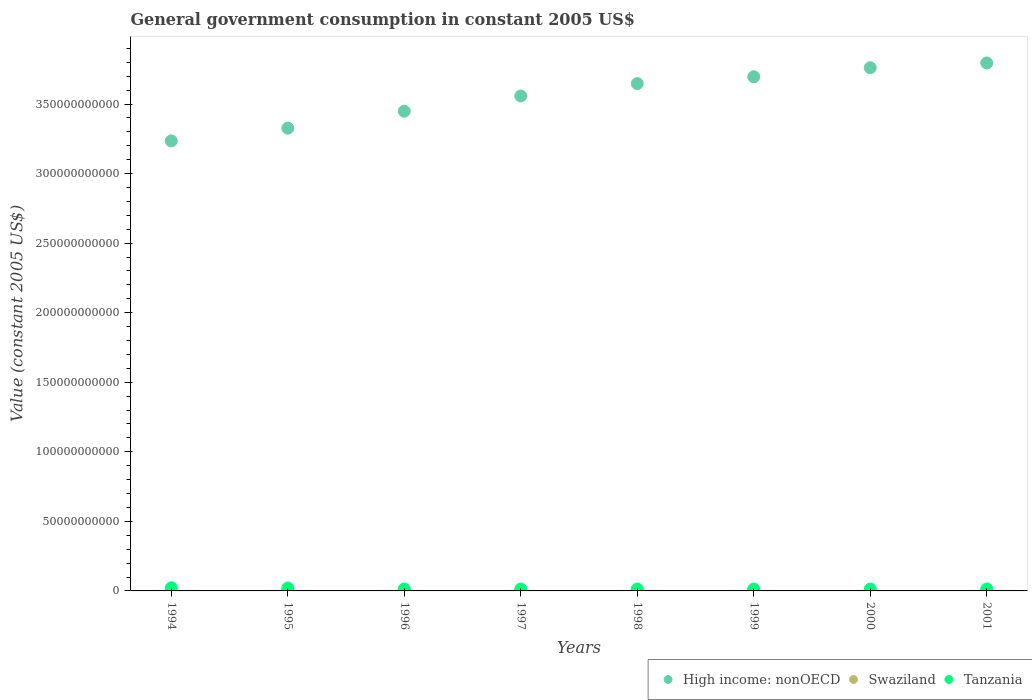What is the government conusmption in Tanzania in 1995?
Keep it short and to the point. 2.11e+09. Across all years, what is the maximum government conusmption in Swaziland?
Offer a terse response. 3.47e+08. Across all years, what is the minimum government conusmption in Tanzania?
Make the answer very short. 1.31e+09. In which year was the government conusmption in Tanzania maximum?
Provide a short and direct response. 1994. In which year was the government conusmption in Tanzania minimum?
Provide a succinct answer. 1999. What is the total government conusmption in High income: nonOECD in the graph?
Your answer should be compact. 2.85e+12. What is the difference between the government conusmption in Swaziland in 1995 and that in 1996?
Offer a very short reply. -5.25e+07. What is the difference between the government conusmption in Tanzania in 1997 and the government conusmption in Swaziland in 1999?
Keep it short and to the point. 1.00e+09. What is the average government conusmption in Swaziland per year?
Give a very brief answer. 2.76e+08. In the year 2001, what is the difference between the government conusmption in High income: nonOECD and government conusmption in Tanzania?
Keep it short and to the point. 3.78e+11. In how many years, is the government conusmption in High income: nonOECD greater than 70000000000 US$?
Your response must be concise. 8. What is the ratio of the government conusmption in Swaziland in 1994 to that in 1995?
Ensure brevity in your answer.  1.01. What is the difference between the highest and the second highest government conusmption in Swaziland?
Offer a terse response. 6.19e+07. What is the difference between the highest and the lowest government conusmption in Swaziland?
Make the answer very short. 1.14e+08. Is the sum of the government conusmption in High income: nonOECD in 1995 and 1999 greater than the maximum government conusmption in Tanzania across all years?
Offer a very short reply. Yes. Does the government conusmption in Swaziland monotonically increase over the years?
Provide a short and direct response. No. Is the government conusmption in Swaziland strictly greater than the government conusmption in Tanzania over the years?
Offer a terse response. No. Is the government conusmption in Swaziland strictly less than the government conusmption in Tanzania over the years?
Provide a short and direct response. Yes. How many dotlines are there?
Your response must be concise. 3. How many years are there in the graph?
Give a very brief answer. 8. Are the values on the major ticks of Y-axis written in scientific E-notation?
Make the answer very short. No. Does the graph contain any zero values?
Your answer should be compact. No. Does the graph contain grids?
Offer a very short reply. No. Where does the legend appear in the graph?
Your answer should be compact. Bottom right. How are the legend labels stacked?
Provide a succinct answer. Horizontal. What is the title of the graph?
Keep it short and to the point. General government consumption in constant 2005 US$. Does "Bahrain" appear as one of the legend labels in the graph?
Ensure brevity in your answer.  No. What is the label or title of the Y-axis?
Provide a succinct answer. Value (constant 2005 US$). What is the Value (constant 2005 US$) in High income: nonOECD in 1994?
Give a very brief answer. 3.24e+11. What is the Value (constant 2005 US$) in Swaziland in 1994?
Provide a succinct answer. 2.36e+08. What is the Value (constant 2005 US$) of Tanzania in 1994?
Your answer should be compact. 2.29e+09. What is the Value (constant 2005 US$) of High income: nonOECD in 1995?
Offer a very short reply. 3.33e+11. What is the Value (constant 2005 US$) in Swaziland in 1995?
Offer a terse response. 2.33e+08. What is the Value (constant 2005 US$) of Tanzania in 1995?
Give a very brief answer. 2.11e+09. What is the Value (constant 2005 US$) in High income: nonOECD in 1996?
Your answer should be very brief. 3.45e+11. What is the Value (constant 2005 US$) of Swaziland in 1996?
Ensure brevity in your answer.  2.86e+08. What is the Value (constant 2005 US$) in Tanzania in 1996?
Make the answer very short. 1.41e+09. What is the Value (constant 2005 US$) in High income: nonOECD in 1997?
Give a very brief answer. 3.56e+11. What is the Value (constant 2005 US$) of Swaziland in 1997?
Your answer should be very brief. 2.72e+08. What is the Value (constant 2005 US$) of Tanzania in 1997?
Give a very brief answer. 1.35e+09. What is the Value (constant 2005 US$) in High income: nonOECD in 1998?
Your response must be concise. 3.65e+11. What is the Value (constant 2005 US$) in Swaziland in 1998?
Keep it short and to the point. 2.79e+08. What is the Value (constant 2005 US$) of Tanzania in 1998?
Provide a short and direct response. 1.33e+09. What is the Value (constant 2005 US$) of High income: nonOECD in 1999?
Give a very brief answer. 3.70e+11. What is the Value (constant 2005 US$) of Swaziland in 1999?
Keep it short and to the point. 3.47e+08. What is the Value (constant 2005 US$) of Tanzania in 1999?
Provide a succinct answer. 1.31e+09. What is the Value (constant 2005 US$) in High income: nonOECD in 2000?
Offer a terse response. 3.76e+11. What is the Value (constant 2005 US$) in Swaziland in 2000?
Give a very brief answer. 2.81e+08. What is the Value (constant 2005 US$) of Tanzania in 2000?
Offer a very short reply. 1.34e+09. What is the Value (constant 2005 US$) in High income: nonOECD in 2001?
Your answer should be very brief. 3.80e+11. What is the Value (constant 2005 US$) of Swaziland in 2001?
Provide a short and direct response. 2.70e+08. What is the Value (constant 2005 US$) of Tanzania in 2001?
Offer a very short reply. 1.42e+09. Across all years, what is the maximum Value (constant 2005 US$) of High income: nonOECD?
Ensure brevity in your answer.  3.80e+11. Across all years, what is the maximum Value (constant 2005 US$) of Swaziland?
Ensure brevity in your answer.  3.47e+08. Across all years, what is the maximum Value (constant 2005 US$) in Tanzania?
Your answer should be very brief. 2.29e+09. Across all years, what is the minimum Value (constant 2005 US$) in High income: nonOECD?
Offer a terse response. 3.24e+11. Across all years, what is the minimum Value (constant 2005 US$) in Swaziland?
Offer a very short reply. 2.33e+08. Across all years, what is the minimum Value (constant 2005 US$) in Tanzania?
Your answer should be very brief. 1.31e+09. What is the total Value (constant 2005 US$) of High income: nonOECD in the graph?
Offer a terse response. 2.85e+12. What is the total Value (constant 2005 US$) in Swaziland in the graph?
Make the answer very short. 2.21e+09. What is the total Value (constant 2005 US$) in Tanzania in the graph?
Your response must be concise. 1.25e+1. What is the difference between the Value (constant 2005 US$) in High income: nonOECD in 1994 and that in 1995?
Provide a succinct answer. -9.17e+09. What is the difference between the Value (constant 2005 US$) in Swaziland in 1994 and that in 1995?
Your answer should be very brief. 3.29e+06. What is the difference between the Value (constant 2005 US$) in Tanzania in 1994 and that in 1995?
Offer a very short reply. 1.83e+08. What is the difference between the Value (constant 2005 US$) of High income: nonOECD in 1994 and that in 1996?
Make the answer very short. -2.14e+1. What is the difference between the Value (constant 2005 US$) in Swaziland in 1994 and that in 1996?
Your answer should be compact. -4.93e+07. What is the difference between the Value (constant 2005 US$) in Tanzania in 1994 and that in 1996?
Keep it short and to the point. 8.76e+08. What is the difference between the Value (constant 2005 US$) in High income: nonOECD in 1994 and that in 1997?
Your answer should be compact. -3.23e+1. What is the difference between the Value (constant 2005 US$) of Swaziland in 1994 and that in 1997?
Your response must be concise. -3.62e+07. What is the difference between the Value (constant 2005 US$) of Tanzania in 1994 and that in 1997?
Your answer should be compact. 9.38e+08. What is the difference between the Value (constant 2005 US$) in High income: nonOECD in 1994 and that in 1998?
Give a very brief answer. -4.12e+1. What is the difference between the Value (constant 2005 US$) of Swaziland in 1994 and that in 1998?
Keep it short and to the point. -4.31e+07. What is the difference between the Value (constant 2005 US$) of Tanzania in 1994 and that in 1998?
Make the answer very short. 9.62e+08. What is the difference between the Value (constant 2005 US$) in High income: nonOECD in 1994 and that in 1999?
Your answer should be very brief. -4.61e+1. What is the difference between the Value (constant 2005 US$) in Swaziland in 1994 and that in 1999?
Your answer should be compact. -1.11e+08. What is the difference between the Value (constant 2005 US$) of Tanzania in 1994 and that in 1999?
Your answer should be compact. 9.83e+08. What is the difference between the Value (constant 2005 US$) of High income: nonOECD in 1994 and that in 2000?
Your answer should be compact. -5.26e+1. What is the difference between the Value (constant 2005 US$) in Swaziland in 1994 and that in 2000?
Offer a very short reply. -4.49e+07. What is the difference between the Value (constant 2005 US$) of Tanzania in 1994 and that in 2000?
Make the answer very short. 9.54e+08. What is the difference between the Value (constant 2005 US$) in High income: nonOECD in 1994 and that in 2001?
Make the answer very short. -5.60e+1. What is the difference between the Value (constant 2005 US$) in Swaziland in 1994 and that in 2001?
Make the answer very short. -3.41e+07. What is the difference between the Value (constant 2005 US$) of Tanzania in 1994 and that in 2001?
Offer a very short reply. 8.74e+08. What is the difference between the Value (constant 2005 US$) of High income: nonOECD in 1995 and that in 1996?
Provide a succinct answer. -1.22e+1. What is the difference between the Value (constant 2005 US$) of Swaziland in 1995 and that in 1996?
Offer a very short reply. -5.25e+07. What is the difference between the Value (constant 2005 US$) of Tanzania in 1995 and that in 1996?
Provide a succinct answer. 6.93e+08. What is the difference between the Value (constant 2005 US$) of High income: nonOECD in 1995 and that in 1997?
Your response must be concise. -2.31e+1. What is the difference between the Value (constant 2005 US$) of Swaziland in 1995 and that in 1997?
Provide a short and direct response. -3.94e+07. What is the difference between the Value (constant 2005 US$) of Tanzania in 1995 and that in 1997?
Provide a succinct answer. 7.56e+08. What is the difference between the Value (constant 2005 US$) in High income: nonOECD in 1995 and that in 1998?
Your answer should be compact. -3.20e+1. What is the difference between the Value (constant 2005 US$) in Swaziland in 1995 and that in 1998?
Make the answer very short. -4.63e+07. What is the difference between the Value (constant 2005 US$) of Tanzania in 1995 and that in 1998?
Keep it short and to the point. 7.80e+08. What is the difference between the Value (constant 2005 US$) of High income: nonOECD in 1995 and that in 1999?
Your response must be concise. -3.70e+1. What is the difference between the Value (constant 2005 US$) in Swaziland in 1995 and that in 1999?
Offer a terse response. -1.14e+08. What is the difference between the Value (constant 2005 US$) in Tanzania in 1995 and that in 1999?
Make the answer very short. 8.00e+08. What is the difference between the Value (constant 2005 US$) in High income: nonOECD in 1995 and that in 2000?
Offer a very short reply. -4.34e+1. What is the difference between the Value (constant 2005 US$) of Swaziland in 1995 and that in 2000?
Offer a terse response. -4.82e+07. What is the difference between the Value (constant 2005 US$) in Tanzania in 1995 and that in 2000?
Offer a terse response. 7.72e+08. What is the difference between the Value (constant 2005 US$) in High income: nonOECD in 1995 and that in 2001?
Make the answer very short. -4.69e+1. What is the difference between the Value (constant 2005 US$) in Swaziland in 1995 and that in 2001?
Your answer should be compact. -3.74e+07. What is the difference between the Value (constant 2005 US$) in Tanzania in 1995 and that in 2001?
Provide a succinct answer. 6.92e+08. What is the difference between the Value (constant 2005 US$) in High income: nonOECD in 1996 and that in 1997?
Make the answer very short. -1.09e+1. What is the difference between the Value (constant 2005 US$) in Swaziland in 1996 and that in 1997?
Offer a very short reply. 1.31e+07. What is the difference between the Value (constant 2005 US$) of Tanzania in 1996 and that in 1997?
Keep it short and to the point. 6.24e+07. What is the difference between the Value (constant 2005 US$) of High income: nonOECD in 1996 and that in 1998?
Keep it short and to the point. -1.99e+1. What is the difference between the Value (constant 2005 US$) of Swaziland in 1996 and that in 1998?
Offer a terse response. 6.20e+06. What is the difference between the Value (constant 2005 US$) of Tanzania in 1996 and that in 1998?
Provide a short and direct response. 8.64e+07. What is the difference between the Value (constant 2005 US$) of High income: nonOECD in 1996 and that in 1999?
Your answer should be compact. -2.48e+1. What is the difference between the Value (constant 2005 US$) in Swaziland in 1996 and that in 1999?
Offer a terse response. -6.19e+07. What is the difference between the Value (constant 2005 US$) of Tanzania in 1996 and that in 1999?
Provide a short and direct response. 1.07e+08. What is the difference between the Value (constant 2005 US$) of High income: nonOECD in 1996 and that in 2000?
Your answer should be very brief. -3.12e+1. What is the difference between the Value (constant 2005 US$) in Swaziland in 1996 and that in 2000?
Your answer should be very brief. 4.34e+06. What is the difference between the Value (constant 2005 US$) in Tanzania in 1996 and that in 2000?
Your answer should be compact. 7.83e+07. What is the difference between the Value (constant 2005 US$) in High income: nonOECD in 1996 and that in 2001?
Your answer should be compact. -3.47e+1. What is the difference between the Value (constant 2005 US$) of Swaziland in 1996 and that in 2001?
Give a very brief answer. 1.51e+07. What is the difference between the Value (constant 2005 US$) of Tanzania in 1996 and that in 2001?
Offer a terse response. -1.82e+06. What is the difference between the Value (constant 2005 US$) of High income: nonOECD in 1997 and that in 1998?
Keep it short and to the point. -8.92e+09. What is the difference between the Value (constant 2005 US$) in Swaziland in 1997 and that in 1998?
Make the answer very short. -6.90e+06. What is the difference between the Value (constant 2005 US$) in Tanzania in 1997 and that in 1998?
Offer a terse response. 2.41e+07. What is the difference between the Value (constant 2005 US$) in High income: nonOECD in 1997 and that in 1999?
Your answer should be compact. -1.38e+1. What is the difference between the Value (constant 2005 US$) in Swaziland in 1997 and that in 1999?
Provide a short and direct response. -7.50e+07. What is the difference between the Value (constant 2005 US$) in Tanzania in 1997 and that in 1999?
Make the answer very short. 4.45e+07. What is the difference between the Value (constant 2005 US$) in High income: nonOECD in 1997 and that in 2000?
Make the answer very short. -2.03e+1. What is the difference between the Value (constant 2005 US$) of Swaziland in 1997 and that in 2000?
Give a very brief answer. -8.76e+06. What is the difference between the Value (constant 2005 US$) of Tanzania in 1997 and that in 2000?
Offer a terse response. 1.59e+07. What is the difference between the Value (constant 2005 US$) in High income: nonOECD in 1997 and that in 2001?
Make the answer very short. -2.37e+1. What is the difference between the Value (constant 2005 US$) of Swaziland in 1997 and that in 2001?
Your response must be concise. 2.03e+06. What is the difference between the Value (constant 2005 US$) of Tanzania in 1997 and that in 2001?
Ensure brevity in your answer.  -6.42e+07. What is the difference between the Value (constant 2005 US$) in High income: nonOECD in 1998 and that in 1999?
Your response must be concise. -4.91e+09. What is the difference between the Value (constant 2005 US$) of Swaziland in 1998 and that in 1999?
Provide a succinct answer. -6.81e+07. What is the difference between the Value (constant 2005 US$) of Tanzania in 1998 and that in 1999?
Keep it short and to the point. 2.05e+07. What is the difference between the Value (constant 2005 US$) in High income: nonOECD in 1998 and that in 2000?
Provide a succinct answer. -1.14e+1. What is the difference between the Value (constant 2005 US$) in Swaziland in 1998 and that in 2000?
Your response must be concise. -1.86e+06. What is the difference between the Value (constant 2005 US$) in Tanzania in 1998 and that in 2000?
Provide a succinct answer. -8.16e+06. What is the difference between the Value (constant 2005 US$) of High income: nonOECD in 1998 and that in 2001?
Your answer should be very brief. -1.48e+1. What is the difference between the Value (constant 2005 US$) in Swaziland in 1998 and that in 2001?
Offer a terse response. 8.94e+06. What is the difference between the Value (constant 2005 US$) of Tanzania in 1998 and that in 2001?
Offer a very short reply. -8.83e+07. What is the difference between the Value (constant 2005 US$) in High income: nonOECD in 1999 and that in 2000?
Offer a terse response. -6.48e+09. What is the difference between the Value (constant 2005 US$) in Swaziland in 1999 and that in 2000?
Make the answer very short. 6.62e+07. What is the difference between the Value (constant 2005 US$) in Tanzania in 1999 and that in 2000?
Provide a succinct answer. -2.86e+07. What is the difference between the Value (constant 2005 US$) in High income: nonOECD in 1999 and that in 2001?
Offer a terse response. -9.92e+09. What is the difference between the Value (constant 2005 US$) of Swaziland in 1999 and that in 2001?
Provide a succinct answer. 7.70e+07. What is the difference between the Value (constant 2005 US$) in Tanzania in 1999 and that in 2001?
Your answer should be compact. -1.09e+08. What is the difference between the Value (constant 2005 US$) in High income: nonOECD in 2000 and that in 2001?
Make the answer very short. -3.43e+09. What is the difference between the Value (constant 2005 US$) of Swaziland in 2000 and that in 2001?
Keep it short and to the point. 1.08e+07. What is the difference between the Value (constant 2005 US$) of Tanzania in 2000 and that in 2001?
Keep it short and to the point. -8.01e+07. What is the difference between the Value (constant 2005 US$) of High income: nonOECD in 1994 and the Value (constant 2005 US$) of Swaziland in 1995?
Make the answer very short. 3.23e+11. What is the difference between the Value (constant 2005 US$) in High income: nonOECD in 1994 and the Value (constant 2005 US$) in Tanzania in 1995?
Provide a succinct answer. 3.21e+11. What is the difference between the Value (constant 2005 US$) in Swaziland in 1994 and the Value (constant 2005 US$) in Tanzania in 1995?
Your response must be concise. -1.87e+09. What is the difference between the Value (constant 2005 US$) in High income: nonOECD in 1994 and the Value (constant 2005 US$) in Swaziland in 1996?
Provide a succinct answer. 3.23e+11. What is the difference between the Value (constant 2005 US$) of High income: nonOECD in 1994 and the Value (constant 2005 US$) of Tanzania in 1996?
Your answer should be compact. 3.22e+11. What is the difference between the Value (constant 2005 US$) of Swaziland in 1994 and the Value (constant 2005 US$) of Tanzania in 1996?
Your response must be concise. -1.18e+09. What is the difference between the Value (constant 2005 US$) in High income: nonOECD in 1994 and the Value (constant 2005 US$) in Swaziland in 1997?
Provide a short and direct response. 3.23e+11. What is the difference between the Value (constant 2005 US$) in High income: nonOECD in 1994 and the Value (constant 2005 US$) in Tanzania in 1997?
Keep it short and to the point. 3.22e+11. What is the difference between the Value (constant 2005 US$) in Swaziland in 1994 and the Value (constant 2005 US$) in Tanzania in 1997?
Offer a terse response. -1.11e+09. What is the difference between the Value (constant 2005 US$) of High income: nonOECD in 1994 and the Value (constant 2005 US$) of Swaziland in 1998?
Your answer should be very brief. 3.23e+11. What is the difference between the Value (constant 2005 US$) in High income: nonOECD in 1994 and the Value (constant 2005 US$) in Tanzania in 1998?
Make the answer very short. 3.22e+11. What is the difference between the Value (constant 2005 US$) of Swaziland in 1994 and the Value (constant 2005 US$) of Tanzania in 1998?
Your answer should be very brief. -1.09e+09. What is the difference between the Value (constant 2005 US$) in High income: nonOECD in 1994 and the Value (constant 2005 US$) in Swaziland in 1999?
Your answer should be compact. 3.23e+11. What is the difference between the Value (constant 2005 US$) in High income: nonOECD in 1994 and the Value (constant 2005 US$) in Tanzania in 1999?
Provide a succinct answer. 3.22e+11. What is the difference between the Value (constant 2005 US$) in Swaziland in 1994 and the Value (constant 2005 US$) in Tanzania in 1999?
Give a very brief answer. -1.07e+09. What is the difference between the Value (constant 2005 US$) in High income: nonOECD in 1994 and the Value (constant 2005 US$) in Swaziland in 2000?
Make the answer very short. 3.23e+11. What is the difference between the Value (constant 2005 US$) of High income: nonOECD in 1994 and the Value (constant 2005 US$) of Tanzania in 2000?
Make the answer very short. 3.22e+11. What is the difference between the Value (constant 2005 US$) of Swaziland in 1994 and the Value (constant 2005 US$) of Tanzania in 2000?
Your response must be concise. -1.10e+09. What is the difference between the Value (constant 2005 US$) of High income: nonOECD in 1994 and the Value (constant 2005 US$) of Swaziland in 2001?
Provide a short and direct response. 3.23e+11. What is the difference between the Value (constant 2005 US$) of High income: nonOECD in 1994 and the Value (constant 2005 US$) of Tanzania in 2001?
Your answer should be compact. 3.22e+11. What is the difference between the Value (constant 2005 US$) of Swaziland in 1994 and the Value (constant 2005 US$) of Tanzania in 2001?
Ensure brevity in your answer.  -1.18e+09. What is the difference between the Value (constant 2005 US$) of High income: nonOECD in 1995 and the Value (constant 2005 US$) of Swaziland in 1996?
Ensure brevity in your answer.  3.32e+11. What is the difference between the Value (constant 2005 US$) of High income: nonOECD in 1995 and the Value (constant 2005 US$) of Tanzania in 1996?
Ensure brevity in your answer.  3.31e+11. What is the difference between the Value (constant 2005 US$) in Swaziland in 1995 and the Value (constant 2005 US$) in Tanzania in 1996?
Your answer should be very brief. -1.18e+09. What is the difference between the Value (constant 2005 US$) in High income: nonOECD in 1995 and the Value (constant 2005 US$) in Swaziland in 1997?
Offer a terse response. 3.32e+11. What is the difference between the Value (constant 2005 US$) of High income: nonOECD in 1995 and the Value (constant 2005 US$) of Tanzania in 1997?
Provide a succinct answer. 3.31e+11. What is the difference between the Value (constant 2005 US$) in Swaziland in 1995 and the Value (constant 2005 US$) in Tanzania in 1997?
Make the answer very short. -1.12e+09. What is the difference between the Value (constant 2005 US$) of High income: nonOECD in 1995 and the Value (constant 2005 US$) of Swaziland in 1998?
Keep it short and to the point. 3.32e+11. What is the difference between the Value (constant 2005 US$) in High income: nonOECD in 1995 and the Value (constant 2005 US$) in Tanzania in 1998?
Give a very brief answer. 3.31e+11. What is the difference between the Value (constant 2005 US$) in Swaziland in 1995 and the Value (constant 2005 US$) in Tanzania in 1998?
Your response must be concise. -1.09e+09. What is the difference between the Value (constant 2005 US$) in High income: nonOECD in 1995 and the Value (constant 2005 US$) in Swaziland in 1999?
Your answer should be compact. 3.32e+11. What is the difference between the Value (constant 2005 US$) of High income: nonOECD in 1995 and the Value (constant 2005 US$) of Tanzania in 1999?
Ensure brevity in your answer.  3.31e+11. What is the difference between the Value (constant 2005 US$) in Swaziland in 1995 and the Value (constant 2005 US$) in Tanzania in 1999?
Ensure brevity in your answer.  -1.07e+09. What is the difference between the Value (constant 2005 US$) in High income: nonOECD in 1995 and the Value (constant 2005 US$) in Swaziland in 2000?
Keep it short and to the point. 3.32e+11. What is the difference between the Value (constant 2005 US$) in High income: nonOECD in 1995 and the Value (constant 2005 US$) in Tanzania in 2000?
Your response must be concise. 3.31e+11. What is the difference between the Value (constant 2005 US$) in Swaziland in 1995 and the Value (constant 2005 US$) in Tanzania in 2000?
Provide a succinct answer. -1.10e+09. What is the difference between the Value (constant 2005 US$) in High income: nonOECD in 1995 and the Value (constant 2005 US$) in Swaziland in 2001?
Give a very brief answer. 3.32e+11. What is the difference between the Value (constant 2005 US$) of High income: nonOECD in 1995 and the Value (constant 2005 US$) of Tanzania in 2001?
Offer a terse response. 3.31e+11. What is the difference between the Value (constant 2005 US$) of Swaziland in 1995 and the Value (constant 2005 US$) of Tanzania in 2001?
Make the answer very short. -1.18e+09. What is the difference between the Value (constant 2005 US$) of High income: nonOECD in 1996 and the Value (constant 2005 US$) of Swaziland in 1997?
Your answer should be very brief. 3.45e+11. What is the difference between the Value (constant 2005 US$) in High income: nonOECD in 1996 and the Value (constant 2005 US$) in Tanzania in 1997?
Keep it short and to the point. 3.44e+11. What is the difference between the Value (constant 2005 US$) of Swaziland in 1996 and the Value (constant 2005 US$) of Tanzania in 1997?
Provide a succinct answer. -1.07e+09. What is the difference between the Value (constant 2005 US$) in High income: nonOECD in 1996 and the Value (constant 2005 US$) in Swaziland in 1998?
Offer a terse response. 3.45e+11. What is the difference between the Value (constant 2005 US$) of High income: nonOECD in 1996 and the Value (constant 2005 US$) of Tanzania in 1998?
Offer a very short reply. 3.44e+11. What is the difference between the Value (constant 2005 US$) of Swaziland in 1996 and the Value (constant 2005 US$) of Tanzania in 1998?
Provide a short and direct response. -1.04e+09. What is the difference between the Value (constant 2005 US$) of High income: nonOECD in 1996 and the Value (constant 2005 US$) of Swaziland in 1999?
Make the answer very short. 3.45e+11. What is the difference between the Value (constant 2005 US$) in High income: nonOECD in 1996 and the Value (constant 2005 US$) in Tanzania in 1999?
Keep it short and to the point. 3.44e+11. What is the difference between the Value (constant 2005 US$) of Swaziland in 1996 and the Value (constant 2005 US$) of Tanzania in 1999?
Offer a terse response. -1.02e+09. What is the difference between the Value (constant 2005 US$) of High income: nonOECD in 1996 and the Value (constant 2005 US$) of Swaziland in 2000?
Ensure brevity in your answer.  3.45e+11. What is the difference between the Value (constant 2005 US$) in High income: nonOECD in 1996 and the Value (constant 2005 US$) in Tanzania in 2000?
Your response must be concise. 3.44e+11. What is the difference between the Value (constant 2005 US$) in Swaziland in 1996 and the Value (constant 2005 US$) in Tanzania in 2000?
Provide a succinct answer. -1.05e+09. What is the difference between the Value (constant 2005 US$) of High income: nonOECD in 1996 and the Value (constant 2005 US$) of Swaziland in 2001?
Your answer should be compact. 3.45e+11. What is the difference between the Value (constant 2005 US$) of High income: nonOECD in 1996 and the Value (constant 2005 US$) of Tanzania in 2001?
Keep it short and to the point. 3.43e+11. What is the difference between the Value (constant 2005 US$) in Swaziland in 1996 and the Value (constant 2005 US$) in Tanzania in 2001?
Offer a terse response. -1.13e+09. What is the difference between the Value (constant 2005 US$) of High income: nonOECD in 1997 and the Value (constant 2005 US$) of Swaziland in 1998?
Offer a very short reply. 3.56e+11. What is the difference between the Value (constant 2005 US$) in High income: nonOECD in 1997 and the Value (constant 2005 US$) in Tanzania in 1998?
Provide a short and direct response. 3.54e+11. What is the difference between the Value (constant 2005 US$) of Swaziland in 1997 and the Value (constant 2005 US$) of Tanzania in 1998?
Keep it short and to the point. -1.05e+09. What is the difference between the Value (constant 2005 US$) in High income: nonOECD in 1997 and the Value (constant 2005 US$) in Swaziland in 1999?
Offer a very short reply. 3.55e+11. What is the difference between the Value (constant 2005 US$) of High income: nonOECD in 1997 and the Value (constant 2005 US$) of Tanzania in 1999?
Give a very brief answer. 3.54e+11. What is the difference between the Value (constant 2005 US$) of Swaziland in 1997 and the Value (constant 2005 US$) of Tanzania in 1999?
Your answer should be compact. -1.03e+09. What is the difference between the Value (constant 2005 US$) of High income: nonOECD in 1997 and the Value (constant 2005 US$) of Swaziland in 2000?
Your response must be concise. 3.56e+11. What is the difference between the Value (constant 2005 US$) of High income: nonOECD in 1997 and the Value (constant 2005 US$) of Tanzania in 2000?
Provide a short and direct response. 3.54e+11. What is the difference between the Value (constant 2005 US$) in Swaziland in 1997 and the Value (constant 2005 US$) in Tanzania in 2000?
Keep it short and to the point. -1.06e+09. What is the difference between the Value (constant 2005 US$) in High income: nonOECD in 1997 and the Value (constant 2005 US$) in Swaziland in 2001?
Your response must be concise. 3.56e+11. What is the difference between the Value (constant 2005 US$) in High income: nonOECD in 1997 and the Value (constant 2005 US$) in Tanzania in 2001?
Provide a succinct answer. 3.54e+11. What is the difference between the Value (constant 2005 US$) in Swaziland in 1997 and the Value (constant 2005 US$) in Tanzania in 2001?
Ensure brevity in your answer.  -1.14e+09. What is the difference between the Value (constant 2005 US$) in High income: nonOECD in 1998 and the Value (constant 2005 US$) in Swaziland in 1999?
Your answer should be very brief. 3.64e+11. What is the difference between the Value (constant 2005 US$) of High income: nonOECD in 1998 and the Value (constant 2005 US$) of Tanzania in 1999?
Your response must be concise. 3.63e+11. What is the difference between the Value (constant 2005 US$) in Swaziland in 1998 and the Value (constant 2005 US$) in Tanzania in 1999?
Offer a terse response. -1.03e+09. What is the difference between the Value (constant 2005 US$) in High income: nonOECD in 1998 and the Value (constant 2005 US$) in Swaziland in 2000?
Offer a terse response. 3.64e+11. What is the difference between the Value (constant 2005 US$) in High income: nonOECD in 1998 and the Value (constant 2005 US$) in Tanzania in 2000?
Offer a terse response. 3.63e+11. What is the difference between the Value (constant 2005 US$) in Swaziland in 1998 and the Value (constant 2005 US$) in Tanzania in 2000?
Make the answer very short. -1.06e+09. What is the difference between the Value (constant 2005 US$) of High income: nonOECD in 1998 and the Value (constant 2005 US$) of Swaziland in 2001?
Make the answer very short. 3.64e+11. What is the difference between the Value (constant 2005 US$) in High income: nonOECD in 1998 and the Value (constant 2005 US$) in Tanzania in 2001?
Offer a terse response. 3.63e+11. What is the difference between the Value (constant 2005 US$) of Swaziland in 1998 and the Value (constant 2005 US$) of Tanzania in 2001?
Give a very brief answer. -1.14e+09. What is the difference between the Value (constant 2005 US$) in High income: nonOECD in 1999 and the Value (constant 2005 US$) in Swaziland in 2000?
Offer a very short reply. 3.69e+11. What is the difference between the Value (constant 2005 US$) of High income: nonOECD in 1999 and the Value (constant 2005 US$) of Tanzania in 2000?
Make the answer very short. 3.68e+11. What is the difference between the Value (constant 2005 US$) of Swaziland in 1999 and the Value (constant 2005 US$) of Tanzania in 2000?
Offer a very short reply. -9.88e+08. What is the difference between the Value (constant 2005 US$) of High income: nonOECD in 1999 and the Value (constant 2005 US$) of Swaziland in 2001?
Offer a very short reply. 3.69e+11. What is the difference between the Value (constant 2005 US$) in High income: nonOECD in 1999 and the Value (constant 2005 US$) in Tanzania in 2001?
Make the answer very short. 3.68e+11. What is the difference between the Value (constant 2005 US$) in Swaziland in 1999 and the Value (constant 2005 US$) in Tanzania in 2001?
Give a very brief answer. -1.07e+09. What is the difference between the Value (constant 2005 US$) in High income: nonOECD in 2000 and the Value (constant 2005 US$) in Swaziland in 2001?
Give a very brief answer. 3.76e+11. What is the difference between the Value (constant 2005 US$) in High income: nonOECD in 2000 and the Value (constant 2005 US$) in Tanzania in 2001?
Offer a terse response. 3.75e+11. What is the difference between the Value (constant 2005 US$) in Swaziland in 2000 and the Value (constant 2005 US$) in Tanzania in 2001?
Your response must be concise. -1.13e+09. What is the average Value (constant 2005 US$) in High income: nonOECD per year?
Ensure brevity in your answer.  3.56e+11. What is the average Value (constant 2005 US$) of Swaziland per year?
Offer a terse response. 2.76e+08. What is the average Value (constant 2005 US$) in Tanzania per year?
Ensure brevity in your answer.  1.57e+09. In the year 1994, what is the difference between the Value (constant 2005 US$) of High income: nonOECD and Value (constant 2005 US$) of Swaziland?
Your response must be concise. 3.23e+11. In the year 1994, what is the difference between the Value (constant 2005 US$) in High income: nonOECD and Value (constant 2005 US$) in Tanzania?
Your answer should be very brief. 3.21e+11. In the year 1994, what is the difference between the Value (constant 2005 US$) in Swaziland and Value (constant 2005 US$) in Tanzania?
Make the answer very short. -2.05e+09. In the year 1995, what is the difference between the Value (constant 2005 US$) in High income: nonOECD and Value (constant 2005 US$) in Swaziland?
Keep it short and to the point. 3.32e+11. In the year 1995, what is the difference between the Value (constant 2005 US$) of High income: nonOECD and Value (constant 2005 US$) of Tanzania?
Your answer should be very brief. 3.31e+11. In the year 1995, what is the difference between the Value (constant 2005 US$) in Swaziland and Value (constant 2005 US$) in Tanzania?
Give a very brief answer. -1.87e+09. In the year 1996, what is the difference between the Value (constant 2005 US$) of High income: nonOECD and Value (constant 2005 US$) of Swaziland?
Keep it short and to the point. 3.45e+11. In the year 1996, what is the difference between the Value (constant 2005 US$) in High income: nonOECD and Value (constant 2005 US$) in Tanzania?
Ensure brevity in your answer.  3.43e+11. In the year 1996, what is the difference between the Value (constant 2005 US$) in Swaziland and Value (constant 2005 US$) in Tanzania?
Keep it short and to the point. -1.13e+09. In the year 1997, what is the difference between the Value (constant 2005 US$) of High income: nonOECD and Value (constant 2005 US$) of Swaziland?
Give a very brief answer. 3.56e+11. In the year 1997, what is the difference between the Value (constant 2005 US$) of High income: nonOECD and Value (constant 2005 US$) of Tanzania?
Provide a short and direct response. 3.54e+11. In the year 1997, what is the difference between the Value (constant 2005 US$) in Swaziland and Value (constant 2005 US$) in Tanzania?
Ensure brevity in your answer.  -1.08e+09. In the year 1998, what is the difference between the Value (constant 2005 US$) of High income: nonOECD and Value (constant 2005 US$) of Swaziland?
Your answer should be compact. 3.64e+11. In the year 1998, what is the difference between the Value (constant 2005 US$) of High income: nonOECD and Value (constant 2005 US$) of Tanzania?
Provide a short and direct response. 3.63e+11. In the year 1998, what is the difference between the Value (constant 2005 US$) of Swaziland and Value (constant 2005 US$) of Tanzania?
Provide a succinct answer. -1.05e+09. In the year 1999, what is the difference between the Value (constant 2005 US$) in High income: nonOECD and Value (constant 2005 US$) in Swaziland?
Ensure brevity in your answer.  3.69e+11. In the year 1999, what is the difference between the Value (constant 2005 US$) in High income: nonOECD and Value (constant 2005 US$) in Tanzania?
Keep it short and to the point. 3.68e+11. In the year 1999, what is the difference between the Value (constant 2005 US$) in Swaziland and Value (constant 2005 US$) in Tanzania?
Offer a terse response. -9.59e+08. In the year 2000, what is the difference between the Value (constant 2005 US$) in High income: nonOECD and Value (constant 2005 US$) in Swaziland?
Your answer should be compact. 3.76e+11. In the year 2000, what is the difference between the Value (constant 2005 US$) of High income: nonOECD and Value (constant 2005 US$) of Tanzania?
Make the answer very short. 3.75e+11. In the year 2000, what is the difference between the Value (constant 2005 US$) of Swaziland and Value (constant 2005 US$) of Tanzania?
Provide a succinct answer. -1.05e+09. In the year 2001, what is the difference between the Value (constant 2005 US$) in High income: nonOECD and Value (constant 2005 US$) in Swaziland?
Give a very brief answer. 3.79e+11. In the year 2001, what is the difference between the Value (constant 2005 US$) in High income: nonOECD and Value (constant 2005 US$) in Tanzania?
Offer a very short reply. 3.78e+11. In the year 2001, what is the difference between the Value (constant 2005 US$) in Swaziland and Value (constant 2005 US$) in Tanzania?
Ensure brevity in your answer.  -1.14e+09. What is the ratio of the Value (constant 2005 US$) in High income: nonOECD in 1994 to that in 1995?
Give a very brief answer. 0.97. What is the ratio of the Value (constant 2005 US$) in Swaziland in 1994 to that in 1995?
Your answer should be compact. 1.01. What is the ratio of the Value (constant 2005 US$) of Tanzania in 1994 to that in 1995?
Offer a terse response. 1.09. What is the ratio of the Value (constant 2005 US$) of High income: nonOECD in 1994 to that in 1996?
Give a very brief answer. 0.94. What is the ratio of the Value (constant 2005 US$) of Swaziland in 1994 to that in 1996?
Provide a short and direct response. 0.83. What is the ratio of the Value (constant 2005 US$) of Tanzania in 1994 to that in 1996?
Offer a terse response. 1.62. What is the ratio of the Value (constant 2005 US$) of High income: nonOECD in 1994 to that in 1997?
Make the answer very short. 0.91. What is the ratio of the Value (constant 2005 US$) in Swaziland in 1994 to that in 1997?
Your response must be concise. 0.87. What is the ratio of the Value (constant 2005 US$) of Tanzania in 1994 to that in 1997?
Make the answer very short. 1.69. What is the ratio of the Value (constant 2005 US$) of High income: nonOECD in 1994 to that in 1998?
Provide a short and direct response. 0.89. What is the ratio of the Value (constant 2005 US$) of Swaziland in 1994 to that in 1998?
Your response must be concise. 0.85. What is the ratio of the Value (constant 2005 US$) of Tanzania in 1994 to that in 1998?
Give a very brief answer. 1.73. What is the ratio of the Value (constant 2005 US$) of High income: nonOECD in 1994 to that in 1999?
Make the answer very short. 0.88. What is the ratio of the Value (constant 2005 US$) in Swaziland in 1994 to that in 1999?
Keep it short and to the point. 0.68. What is the ratio of the Value (constant 2005 US$) of Tanzania in 1994 to that in 1999?
Give a very brief answer. 1.75. What is the ratio of the Value (constant 2005 US$) in High income: nonOECD in 1994 to that in 2000?
Make the answer very short. 0.86. What is the ratio of the Value (constant 2005 US$) in Swaziland in 1994 to that in 2000?
Offer a terse response. 0.84. What is the ratio of the Value (constant 2005 US$) of Tanzania in 1994 to that in 2000?
Ensure brevity in your answer.  1.71. What is the ratio of the Value (constant 2005 US$) of High income: nonOECD in 1994 to that in 2001?
Keep it short and to the point. 0.85. What is the ratio of the Value (constant 2005 US$) in Swaziland in 1994 to that in 2001?
Your answer should be compact. 0.87. What is the ratio of the Value (constant 2005 US$) of Tanzania in 1994 to that in 2001?
Your answer should be very brief. 1.62. What is the ratio of the Value (constant 2005 US$) in High income: nonOECD in 1995 to that in 1996?
Offer a terse response. 0.96. What is the ratio of the Value (constant 2005 US$) of Swaziland in 1995 to that in 1996?
Your response must be concise. 0.82. What is the ratio of the Value (constant 2005 US$) in Tanzania in 1995 to that in 1996?
Offer a very short reply. 1.49. What is the ratio of the Value (constant 2005 US$) in High income: nonOECD in 1995 to that in 1997?
Make the answer very short. 0.94. What is the ratio of the Value (constant 2005 US$) in Swaziland in 1995 to that in 1997?
Your answer should be compact. 0.86. What is the ratio of the Value (constant 2005 US$) of Tanzania in 1995 to that in 1997?
Provide a short and direct response. 1.56. What is the ratio of the Value (constant 2005 US$) of High income: nonOECD in 1995 to that in 1998?
Keep it short and to the point. 0.91. What is the ratio of the Value (constant 2005 US$) in Swaziland in 1995 to that in 1998?
Make the answer very short. 0.83. What is the ratio of the Value (constant 2005 US$) of Tanzania in 1995 to that in 1998?
Provide a succinct answer. 1.59. What is the ratio of the Value (constant 2005 US$) of Swaziland in 1995 to that in 1999?
Your answer should be very brief. 0.67. What is the ratio of the Value (constant 2005 US$) of Tanzania in 1995 to that in 1999?
Ensure brevity in your answer.  1.61. What is the ratio of the Value (constant 2005 US$) of High income: nonOECD in 1995 to that in 2000?
Ensure brevity in your answer.  0.88. What is the ratio of the Value (constant 2005 US$) in Swaziland in 1995 to that in 2000?
Provide a short and direct response. 0.83. What is the ratio of the Value (constant 2005 US$) in Tanzania in 1995 to that in 2000?
Ensure brevity in your answer.  1.58. What is the ratio of the Value (constant 2005 US$) of High income: nonOECD in 1995 to that in 2001?
Offer a terse response. 0.88. What is the ratio of the Value (constant 2005 US$) of Swaziland in 1995 to that in 2001?
Provide a succinct answer. 0.86. What is the ratio of the Value (constant 2005 US$) in Tanzania in 1995 to that in 2001?
Make the answer very short. 1.49. What is the ratio of the Value (constant 2005 US$) of High income: nonOECD in 1996 to that in 1997?
Make the answer very short. 0.97. What is the ratio of the Value (constant 2005 US$) in Swaziland in 1996 to that in 1997?
Keep it short and to the point. 1.05. What is the ratio of the Value (constant 2005 US$) of Tanzania in 1996 to that in 1997?
Ensure brevity in your answer.  1.05. What is the ratio of the Value (constant 2005 US$) in High income: nonOECD in 1996 to that in 1998?
Keep it short and to the point. 0.95. What is the ratio of the Value (constant 2005 US$) of Swaziland in 1996 to that in 1998?
Your response must be concise. 1.02. What is the ratio of the Value (constant 2005 US$) in Tanzania in 1996 to that in 1998?
Offer a terse response. 1.07. What is the ratio of the Value (constant 2005 US$) of High income: nonOECD in 1996 to that in 1999?
Offer a very short reply. 0.93. What is the ratio of the Value (constant 2005 US$) of Swaziland in 1996 to that in 1999?
Your answer should be very brief. 0.82. What is the ratio of the Value (constant 2005 US$) of Tanzania in 1996 to that in 1999?
Make the answer very short. 1.08. What is the ratio of the Value (constant 2005 US$) in High income: nonOECD in 1996 to that in 2000?
Give a very brief answer. 0.92. What is the ratio of the Value (constant 2005 US$) of Swaziland in 1996 to that in 2000?
Make the answer very short. 1.02. What is the ratio of the Value (constant 2005 US$) of Tanzania in 1996 to that in 2000?
Your response must be concise. 1.06. What is the ratio of the Value (constant 2005 US$) in High income: nonOECD in 1996 to that in 2001?
Keep it short and to the point. 0.91. What is the ratio of the Value (constant 2005 US$) of Swaziland in 1996 to that in 2001?
Ensure brevity in your answer.  1.06. What is the ratio of the Value (constant 2005 US$) of Tanzania in 1996 to that in 2001?
Offer a terse response. 1. What is the ratio of the Value (constant 2005 US$) of High income: nonOECD in 1997 to that in 1998?
Your response must be concise. 0.98. What is the ratio of the Value (constant 2005 US$) in Swaziland in 1997 to that in 1998?
Provide a short and direct response. 0.98. What is the ratio of the Value (constant 2005 US$) in Tanzania in 1997 to that in 1998?
Offer a terse response. 1.02. What is the ratio of the Value (constant 2005 US$) in High income: nonOECD in 1997 to that in 1999?
Offer a terse response. 0.96. What is the ratio of the Value (constant 2005 US$) in Swaziland in 1997 to that in 1999?
Ensure brevity in your answer.  0.78. What is the ratio of the Value (constant 2005 US$) in Tanzania in 1997 to that in 1999?
Make the answer very short. 1.03. What is the ratio of the Value (constant 2005 US$) in High income: nonOECD in 1997 to that in 2000?
Provide a succinct answer. 0.95. What is the ratio of the Value (constant 2005 US$) of Swaziland in 1997 to that in 2000?
Keep it short and to the point. 0.97. What is the ratio of the Value (constant 2005 US$) of Tanzania in 1997 to that in 2000?
Ensure brevity in your answer.  1.01. What is the ratio of the Value (constant 2005 US$) in High income: nonOECD in 1997 to that in 2001?
Keep it short and to the point. 0.94. What is the ratio of the Value (constant 2005 US$) of Swaziland in 1997 to that in 2001?
Provide a short and direct response. 1.01. What is the ratio of the Value (constant 2005 US$) in Tanzania in 1997 to that in 2001?
Give a very brief answer. 0.95. What is the ratio of the Value (constant 2005 US$) in High income: nonOECD in 1998 to that in 1999?
Give a very brief answer. 0.99. What is the ratio of the Value (constant 2005 US$) of Swaziland in 1998 to that in 1999?
Offer a terse response. 0.8. What is the ratio of the Value (constant 2005 US$) of Tanzania in 1998 to that in 1999?
Your answer should be very brief. 1.02. What is the ratio of the Value (constant 2005 US$) of High income: nonOECD in 1998 to that in 2000?
Offer a terse response. 0.97. What is the ratio of the Value (constant 2005 US$) in Swaziland in 1998 to that in 2000?
Your answer should be compact. 0.99. What is the ratio of the Value (constant 2005 US$) of Tanzania in 1998 to that in 2000?
Give a very brief answer. 0.99. What is the ratio of the Value (constant 2005 US$) in High income: nonOECD in 1998 to that in 2001?
Your answer should be compact. 0.96. What is the ratio of the Value (constant 2005 US$) of Swaziland in 1998 to that in 2001?
Ensure brevity in your answer.  1.03. What is the ratio of the Value (constant 2005 US$) of Tanzania in 1998 to that in 2001?
Your response must be concise. 0.94. What is the ratio of the Value (constant 2005 US$) in High income: nonOECD in 1999 to that in 2000?
Your response must be concise. 0.98. What is the ratio of the Value (constant 2005 US$) in Swaziland in 1999 to that in 2000?
Your answer should be compact. 1.24. What is the ratio of the Value (constant 2005 US$) of Tanzania in 1999 to that in 2000?
Give a very brief answer. 0.98. What is the ratio of the Value (constant 2005 US$) in High income: nonOECD in 1999 to that in 2001?
Your answer should be very brief. 0.97. What is the ratio of the Value (constant 2005 US$) in Swaziland in 1999 to that in 2001?
Offer a terse response. 1.28. What is the ratio of the Value (constant 2005 US$) of Tanzania in 1999 to that in 2001?
Ensure brevity in your answer.  0.92. What is the ratio of the Value (constant 2005 US$) of Swaziland in 2000 to that in 2001?
Make the answer very short. 1.04. What is the ratio of the Value (constant 2005 US$) in Tanzania in 2000 to that in 2001?
Provide a short and direct response. 0.94. What is the difference between the highest and the second highest Value (constant 2005 US$) of High income: nonOECD?
Ensure brevity in your answer.  3.43e+09. What is the difference between the highest and the second highest Value (constant 2005 US$) in Swaziland?
Your response must be concise. 6.19e+07. What is the difference between the highest and the second highest Value (constant 2005 US$) in Tanzania?
Your answer should be compact. 1.83e+08. What is the difference between the highest and the lowest Value (constant 2005 US$) in High income: nonOECD?
Your answer should be very brief. 5.60e+1. What is the difference between the highest and the lowest Value (constant 2005 US$) in Swaziland?
Provide a short and direct response. 1.14e+08. What is the difference between the highest and the lowest Value (constant 2005 US$) in Tanzania?
Give a very brief answer. 9.83e+08. 